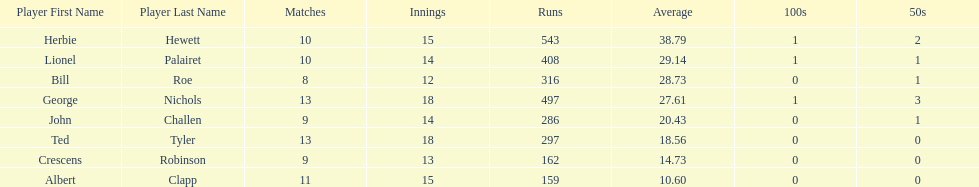How many players played more than 10 matches? 3. 